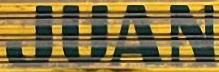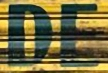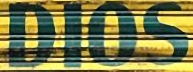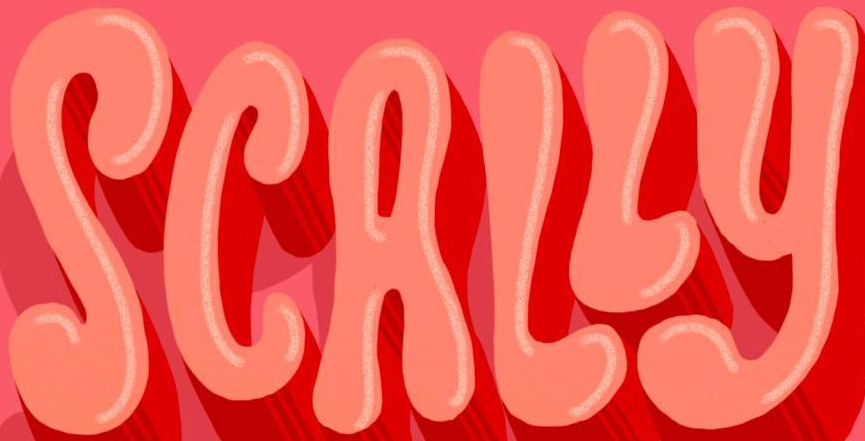What text appears in these images from left to right, separated by a semicolon? JUAN; DE; DIOS; SCALLY 